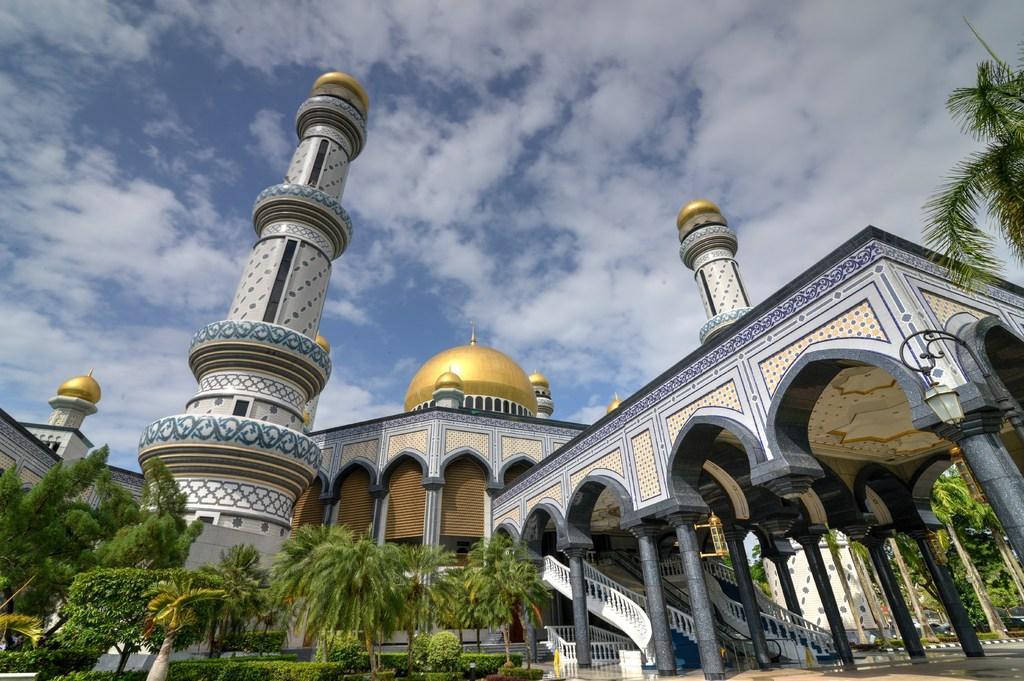Can you describe this image briefly? In this picture we can observe two pillars. We can observe gold color dome on this building. There are some trees in this picture. In the background there is a sky with clouds. 